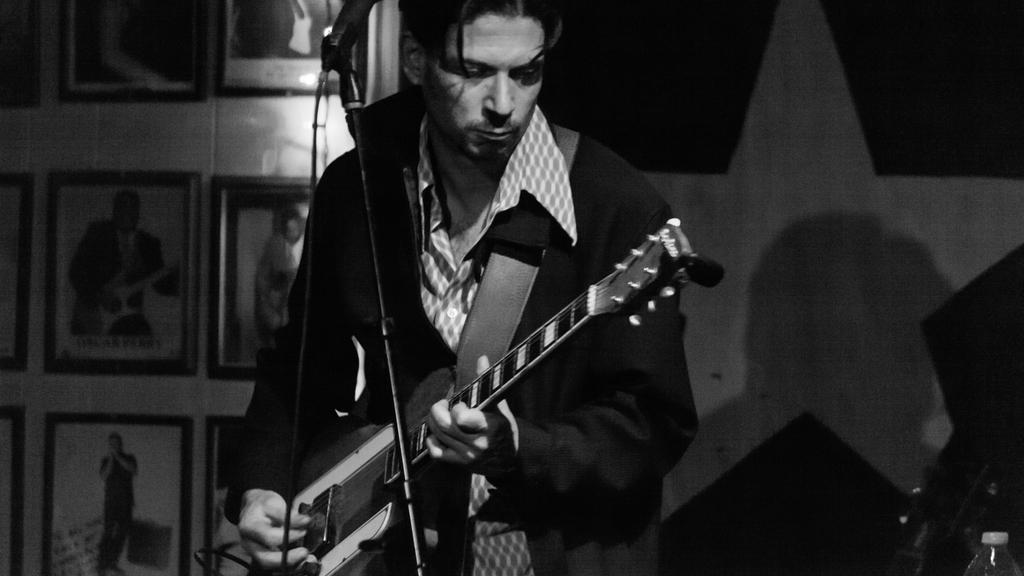In one or two sentences, can you explain what this image depicts? In this image there is a person standing and playing guitar. At the back there are photo frames, at the front there is a bottle and microphone. 